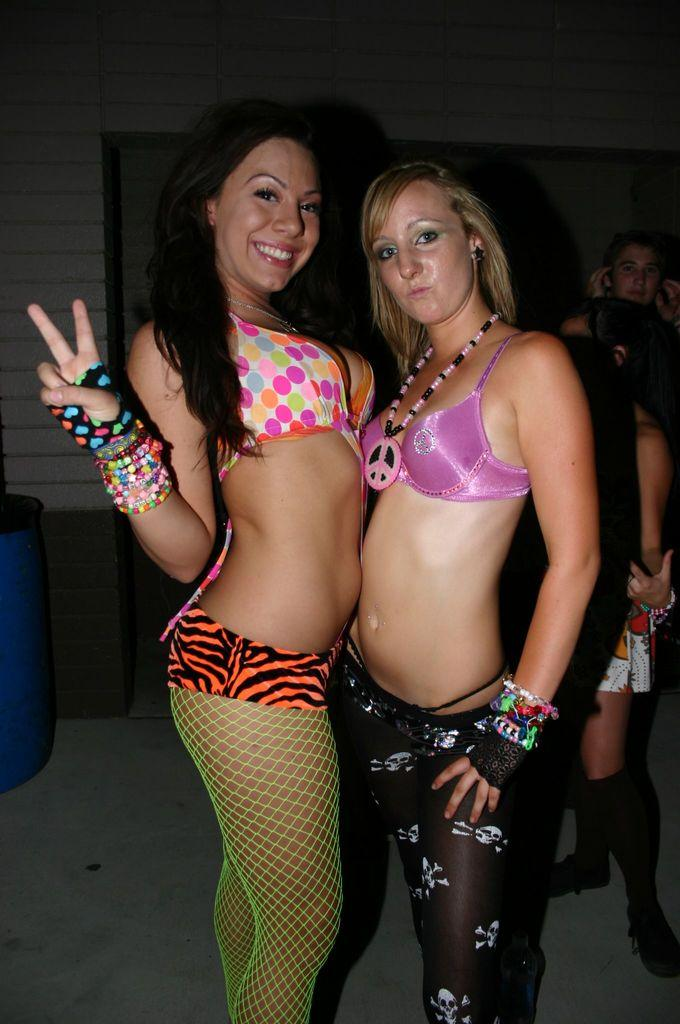How many women are in the image? There are two women in the image. What colors are featured in the dress of the first woman? The first woman is wearing a pink and black dress. What colors are featured in the dress of the second woman? The second woman is wearing an orange and green dress. Can you describe the people visible behind the two women? Unfortunately, the provided facts do not give any information about the people behind the two women. What type of camp can be seen in the background of the image? There is no camp visible in the image; it only features two women and their dresses. 